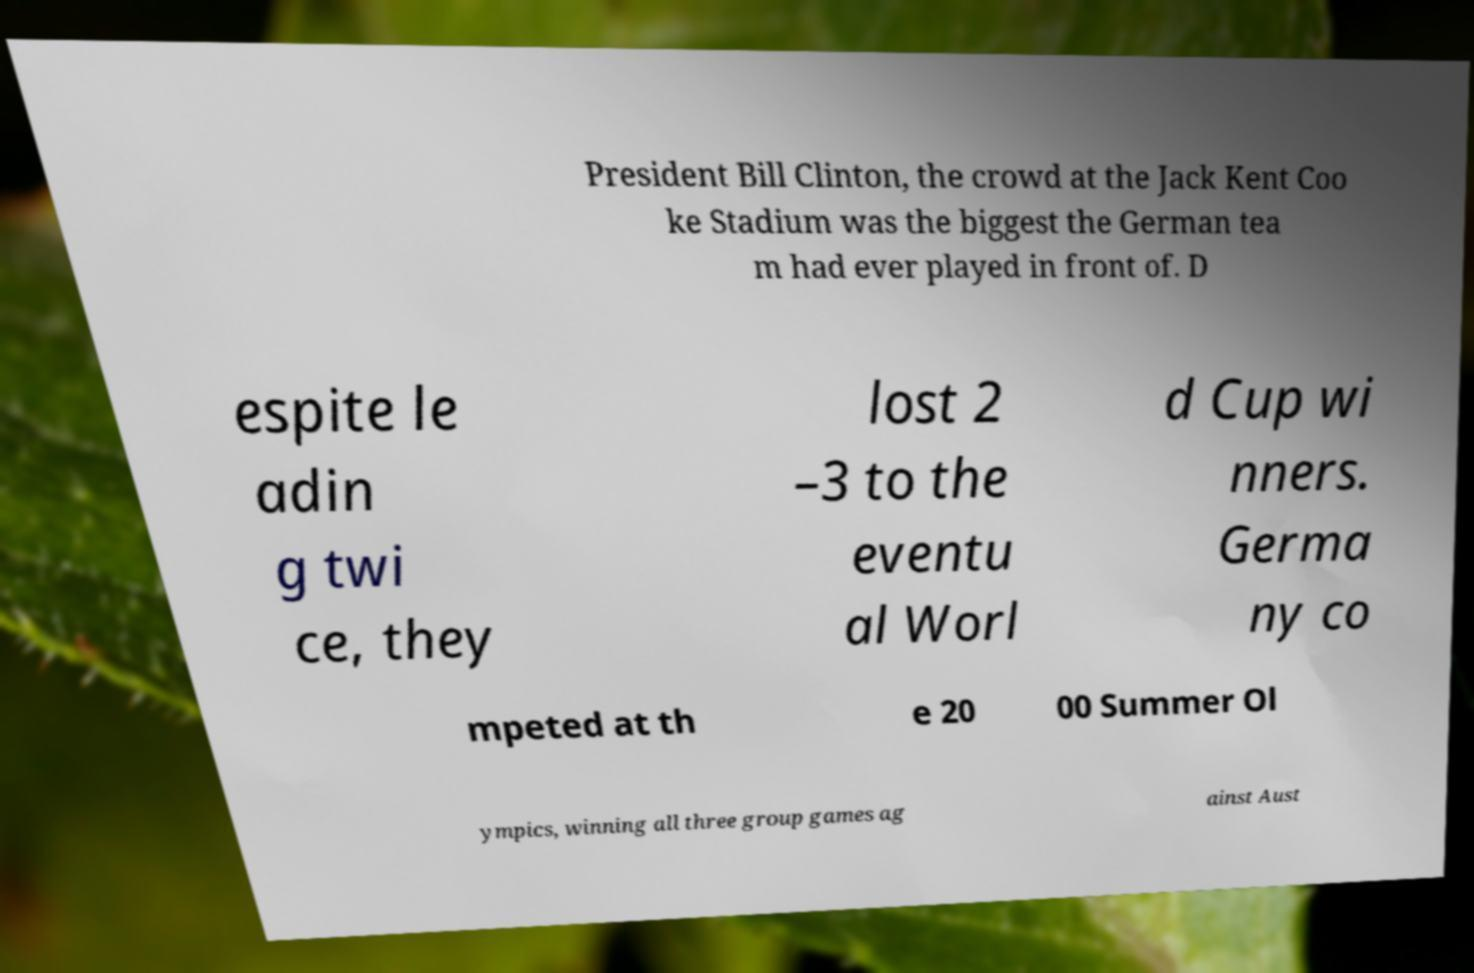Please identify and transcribe the text found in this image. President Bill Clinton, the crowd at the Jack Kent Coo ke Stadium was the biggest the German tea m had ever played in front of. D espite le adin g twi ce, they lost 2 –3 to the eventu al Worl d Cup wi nners. Germa ny co mpeted at th e 20 00 Summer Ol ympics, winning all three group games ag ainst Aust 